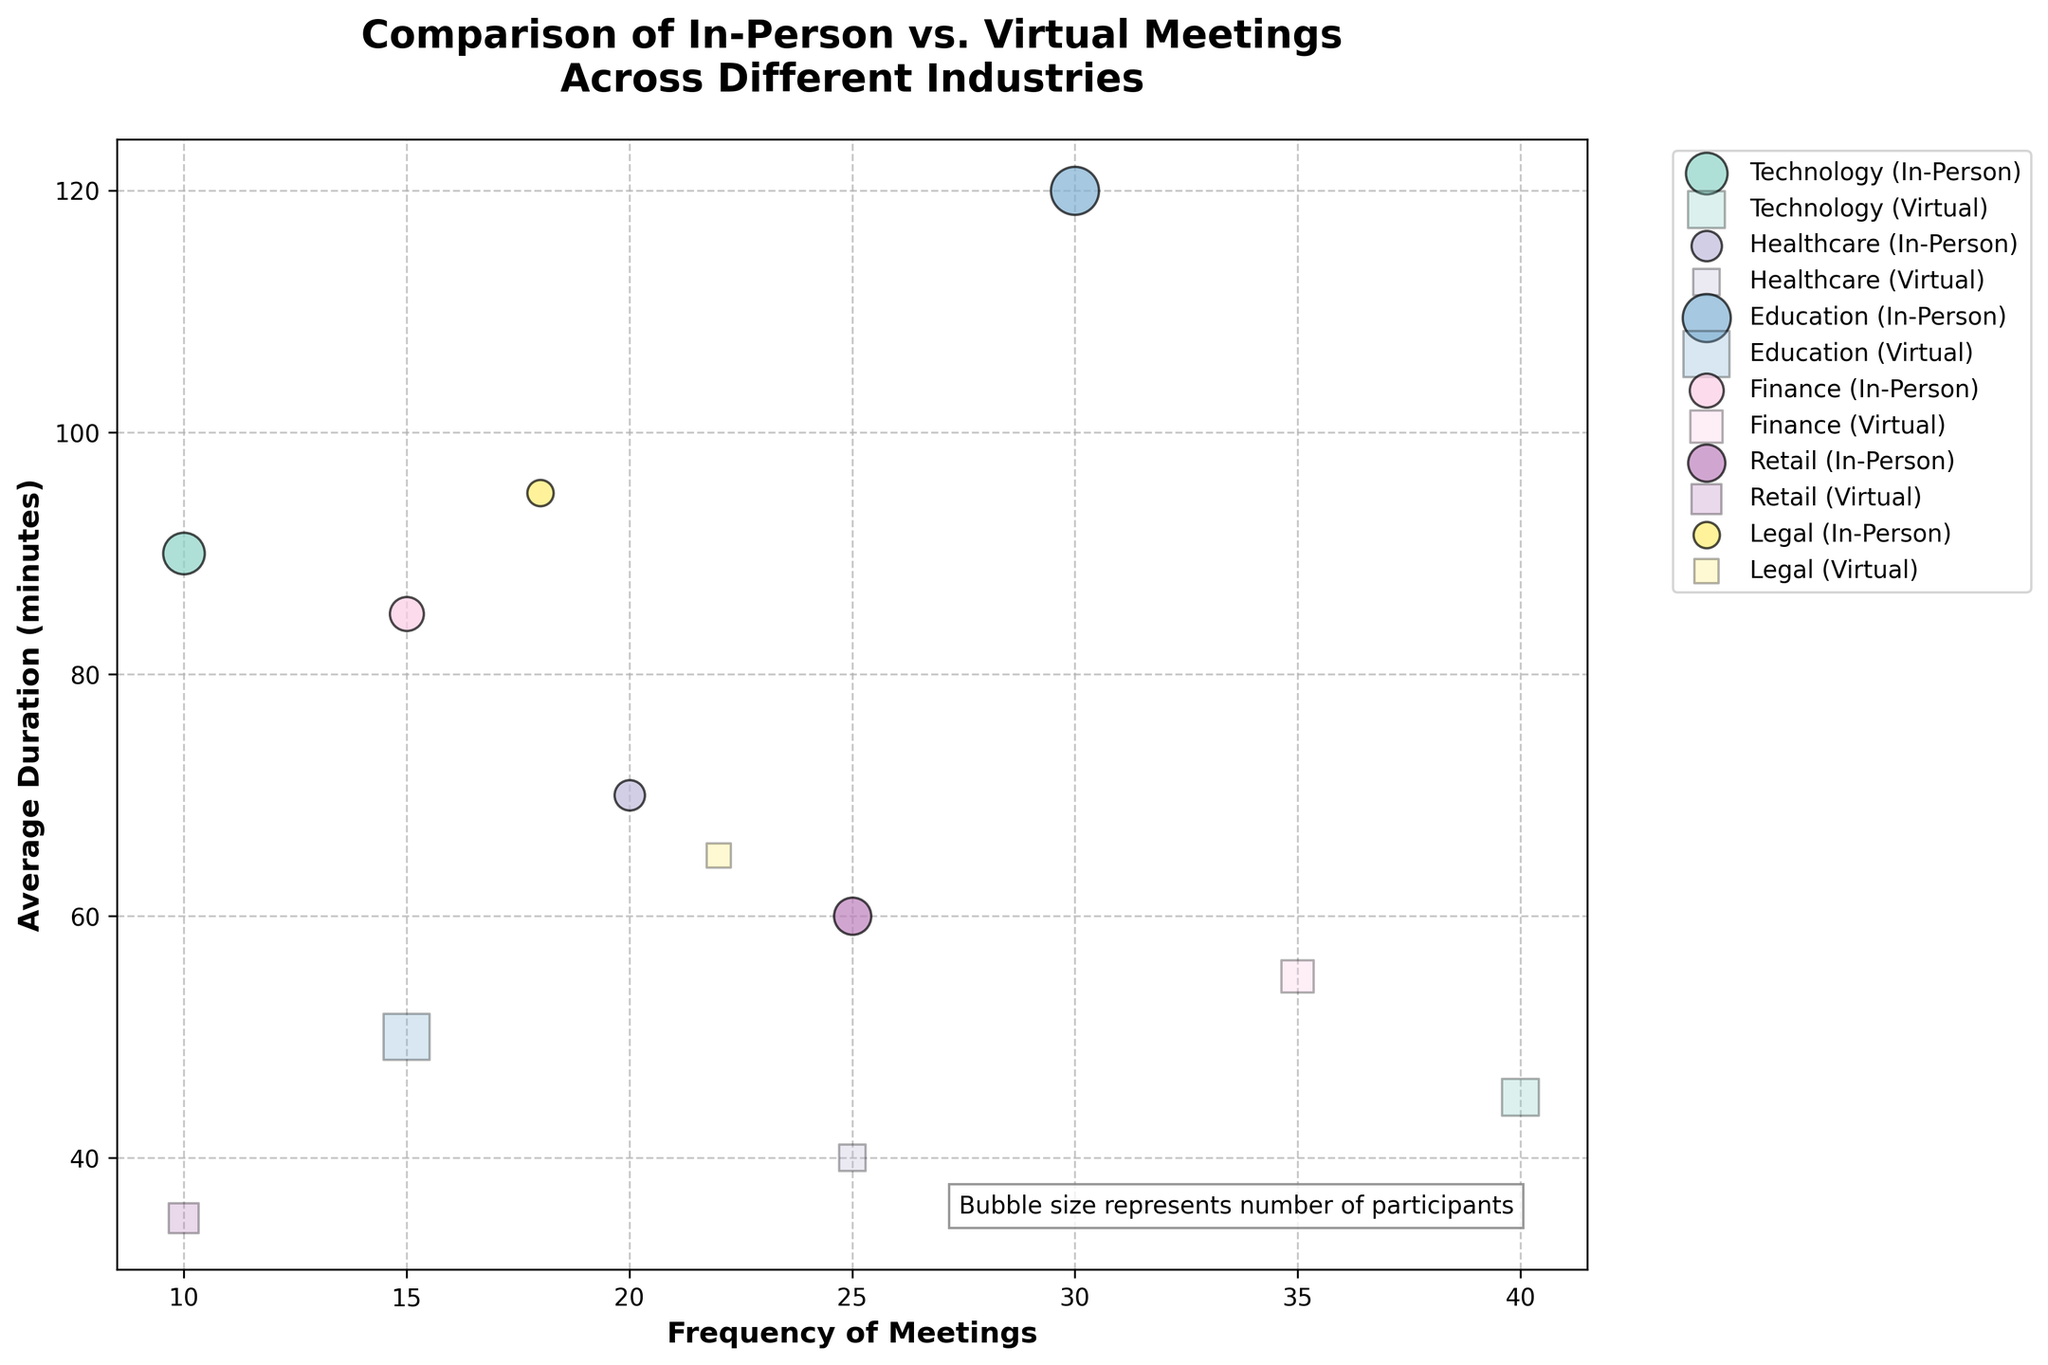What's the title of the figure? The title of the figure is prominently displayed at the top of the plot. It reads: "Comparison of In-Person vs. Virtual Meetings Across Different Industries".
Answer: Comparison of In-Person vs. Virtual Meetings Across Different Industries What does the bubble size represent in the figure? The bubble size is described within the figure text box, which indicates that it represents the number of participants in the meetings.
Answer: number of participants In which industry do in-person meetings have the highest average duration? By examining the y-axis where "Average Duration (minutes)" is plotted, we look for the highest point among the in-person meeting bubbles. The Education industry's in-person bubble is the highest, indicating it has the highest average duration.
Answer: Education How many in-person meetings per month are held in the Retail sector? By locating the Retail sector on the x-axis for in-person meetings, we see that the frequency is represented by the bubble at the 25 mark.
Answer: 25 Compare the average duration of virtual meetings between Healthcare and Legal sectors. Which one is higher? Checking the y-axis values for the virtual meeting bubbles in Healthcare and Legal, we find that the average duration for Legal (65) is higher than Healthcare (40).
Answer: Legal Which industry has the least frequent virtual meetings? The fewer numbers on the x-axis indicate less frequent meetings. Retail's virtual meetings, marked at 10, are the least frequent compared to other industries.
Answer: Retail Compare the frequency of in-person meetings between Finance and Technology sectors. Which has more monthly in-person meetings? Locate the in-person bubbles on the x-axis for Finance and Technology sectors and compare. Technology has 10, while Finance has 15, indicating Finance has more in-person meetings.
Answer: Finance What is the relationship between duration and frequency of meetings in the Education sector? In the Education sector, compare both in-person and virtual meeting bubbles. In-person meetings have higher duration and frequency (30, 120), while virtual meetings have lower frequency and shorter duration (15, 50). This suggests an inverse relationship where virtual meetings are shorter and less frequent compared to in-person.
Answer: In-person meetings more frequent and longer Which mode of meeting in the Technology sector has more participants on average? Assess the bubble sizes in Technology sector for both in-person and virtual meetings. In-person meetings have a larger bubble size (15 participants) compared to virtual (12 participants), indicating more participants on average.
Answer: In-person meetings How does the average duration of meetings in the Legal sector compare between in-person and virtual modes? Observing the Legal sector for both in-person and virtual meeting bubbles on the y-axis, in-person meetings have an average duration greater (95 minutes) than virtual meetings (65 minutes).
Answer: In-person meetings have longer duration 